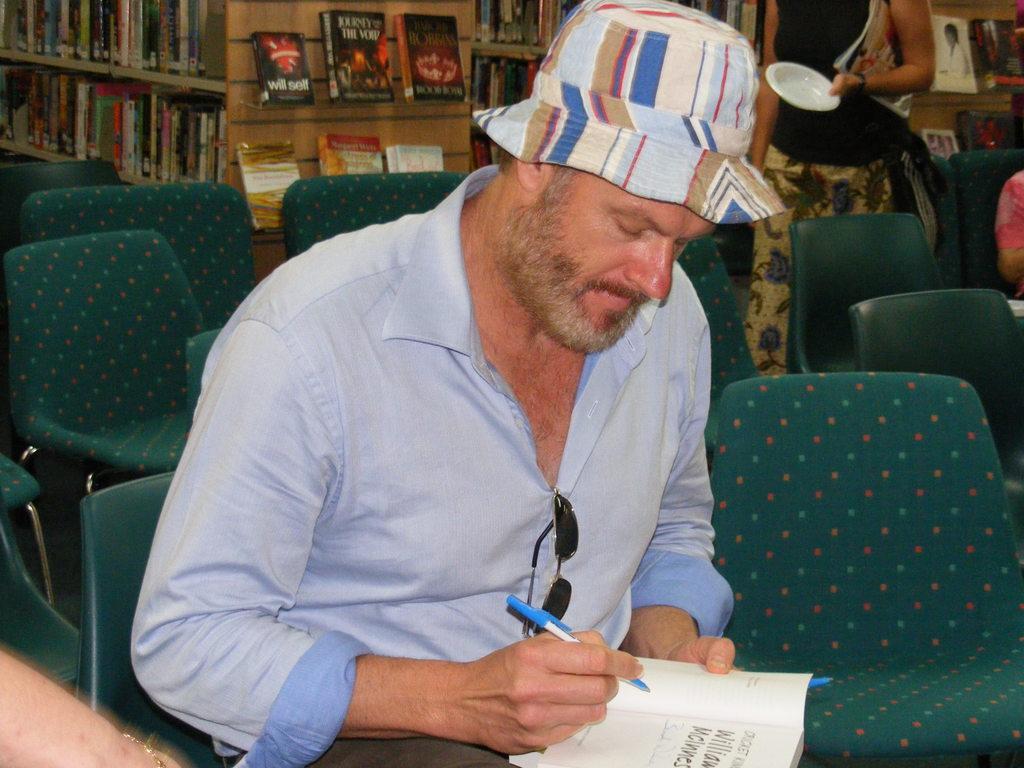Can you describe this image briefly? In this image I can see a m an sitting on a chair. In the background I can see number of chairs, number of books and few more people. 